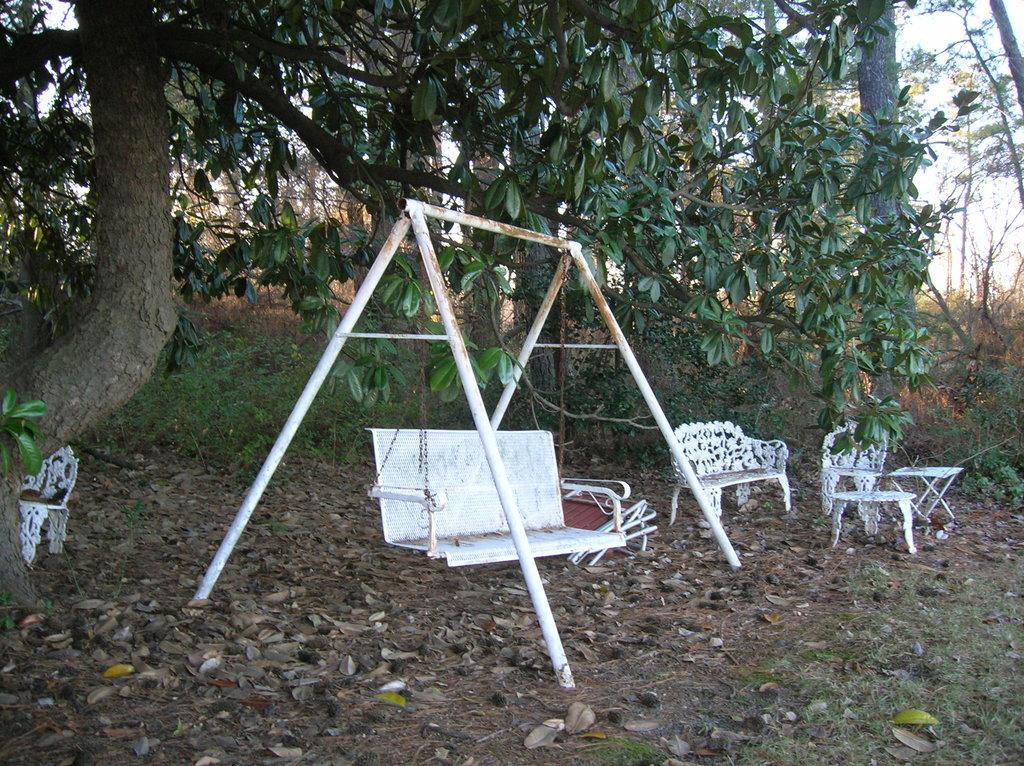How would you summarize this image in a sentence or two? In the image in the center there is a swing, and there are some chairs and table. At the bottom there are some dry leaves and grass, and in the background there are some trees and sky. 